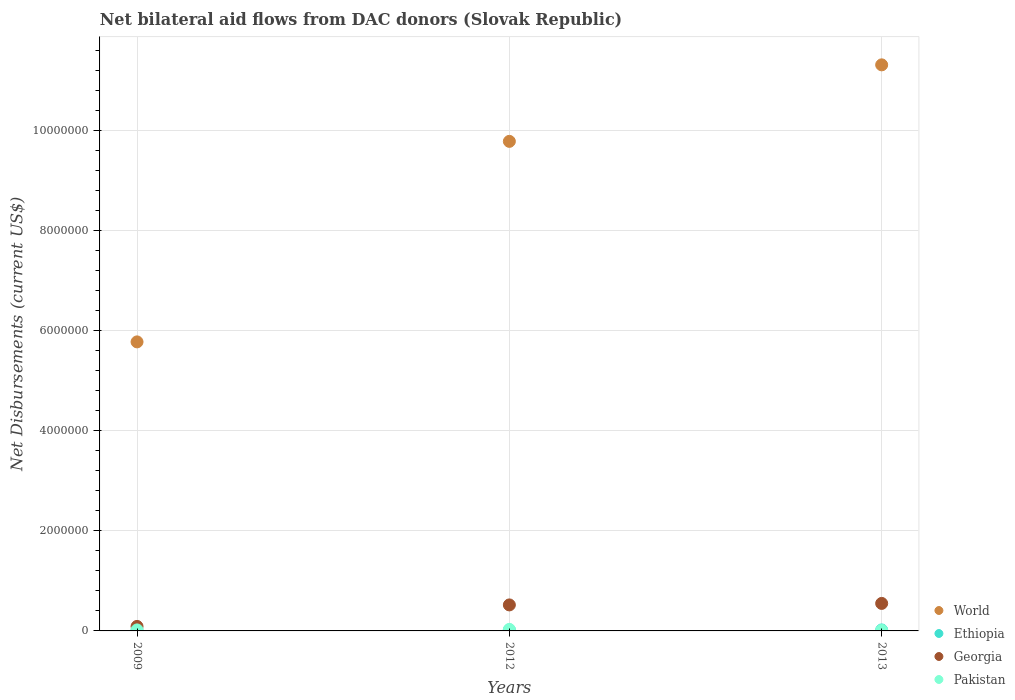Is the number of dotlines equal to the number of legend labels?
Your answer should be very brief. Yes. Across all years, what is the maximum net bilateral aid flows in Pakistan?
Your response must be concise. 3.00e+04. Across all years, what is the minimum net bilateral aid flows in World?
Your answer should be very brief. 5.78e+06. What is the total net bilateral aid flows in Pakistan in the graph?
Make the answer very short. 6.00e+04. What is the difference between the net bilateral aid flows in Georgia in 2013 and the net bilateral aid flows in Pakistan in 2012?
Your answer should be very brief. 5.20e+05. In the year 2009, what is the difference between the net bilateral aid flows in Pakistan and net bilateral aid flows in World?
Make the answer very short. -5.76e+06. What is the difference between the highest and the lowest net bilateral aid flows in Ethiopia?
Make the answer very short. 10000. Is the sum of the net bilateral aid flows in Ethiopia in 2012 and 2013 greater than the maximum net bilateral aid flows in World across all years?
Provide a succinct answer. No. Is it the case that in every year, the sum of the net bilateral aid flows in Pakistan and net bilateral aid flows in Georgia  is greater than the sum of net bilateral aid flows in Ethiopia and net bilateral aid flows in World?
Offer a very short reply. No. Does the net bilateral aid flows in Georgia monotonically increase over the years?
Keep it short and to the point. Yes. Is the net bilateral aid flows in World strictly greater than the net bilateral aid flows in Pakistan over the years?
Ensure brevity in your answer.  Yes. Are the values on the major ticks of Y-axis written in scientific E-notation?
Provide a succinct answer. No. Does the graph contain any zero values?
Offer a terse response. No. Does the graph contain grids?
Offer a terse response. Yes. How many legend labels are there?
Your answer should be very brief. 4. What is the title of the graph?
Your answer should be very brief. Net bilateral aid flows from DAC donors (Slovak Republic). Does "Latin America(developing only)" appear as one of the legend labels in the graph?
Provide a short and direct response. No. What is the label or title of the Y-axis?
Your response must be concise. Net Disbursements (current US$). What is the Net Disbursements (current US$) in World in 2009?
Give a very brief answer. 5.78e+06. What is the Net Disbursements (current US$) of Ethiopia in 2009?
Offer a very short reply. 10000. What is the Net Disbursements (current US$) in World in 2012?
Offer a very short reply. 9.79e+06. What is the Net Disbursements (current US$) of Ethiopia in 2012?
Your response must be concise. 2.00e+04. What is the Net Disbursements (current US$) in Georgia in 2012?
Provide a succinct answer. 5.20e+05. What is the Net Disbursements (current US$) in World in 2013?
Offer a very short reply. 1.13e+07. What is the Net Disbursements (current US$) of Ethiopia in 2013?
Your answer should be very brief. 2.00e+04. What is the Net Disbursements (current US$) in Georgia in 2013?
Your answer should be compact. 5.50e+05. Across all years, what is the maximum Net Disbursements (current US$) in World?
Give a very brief answer. 1.13e+07. Across all years, what is the maximum Net Disbursements (current US$) of Ethiopia?
Offer a terse response. 2.00e+04. Across all years, what is the minimum Net Disbursements (current US$) in World?
Provide a succinct answer. 5.78e+06. Across all years, what is the minimum Net Disbursements (current US$) in Ethiopia?
Your answer should be compact. 10000. Across all years, what is the minimum Net Disbursements (current US$) of Pakistan?
Provide a succinct answer. 10000. What is the total Net Disbursements (current US$) in World in the graph?
Offer a terse response. 2.69e+07. What is the total Net Disbursements (current US$) in Georgia in the graph?
Offer a terse response. 1.16e+06. What is the total Net Disbursements (current US$) of Pakistan in the graph?
Ensure brevity in your answer.  6.00e+04. What is the difference between the Net Disbursements (current US$) of World in 2009 and that in 2012?
Your answer should be very brief. -4.01e+06. What is the difference between the Net Disbursements (current US$) in Ethiopia in 2009 and that in 2012?
Your response must be concise. -10000. What is the difference between the Net Disbursements (current US$) in Georgia in 2009 and that in 2012?
Offer a terse response. -4.30e+05. What is the difference between the Net Disbursements (current US$) in Pakistan in 2009 and that in 2012?
Ensure brevity in your answer.  -10000. What is the difference between the Net Disbursements (current US$) of World in 2009 and that in 2013?
Your answer should be compact. -5.54e+06. What is the difference between the Net Disbursements (current US$) of Georgia in 2009 and that in 2013?
Your answer should be very brief. -4.60e+05. What is the difference between the Net Disbursements (current US$) in World in 2012 and that in 2013?
Your response must be concise. -1.53e+06. What is the difference between the Net Disbursements (current US$) in Ethiopia in 2012 and that in 2013?
Provide a short and direct response. 0. What is the difference between the Net Disbursements (current US$) of Pakistan in 2012 and that in 2013?
Make the answer very short. 2.00e+04. What is the difference between the Net Disbursements (current US$) in World in 2009 and the Net Disbursements (current US$) in Ethiopia in 2012?
Your response must be concise. 5.76e+06. What is the difference between the Net Disbursements (current US$) in World in 2009 and the Net Disbursements (current US$) in Georgia in 2012?
Your answer should be very brief. 5.26e+06. What is the difference between the Net Disbursements (current US$) in World in 2009 and the Net Disbursements (current US$) in Pakistan in 2012?
Make the answer very short. 5.75e+06. What is the difference between the Net Disbursements (current US$) in Ethiopia in 2009 and the Net Disbursements (current US$) in Georgia in 2012?
Your response must be concise. -5.10e+05. What is the difference between the Net Disbursements (current US$) of Ethiopia in 2009 and the Net Disbursements (current US$) of Pakistan in 2012?
Give a very brief answer. -2.00e+04. What is the difference between the Net Disbursements (current US$) in World in 2009 and the Net Disbursements (current US$) in Ethiopia in 2013?
Make the answer very short. 5.76e+06. What is the difference between the Net Disbursements (current US$) in World in 2009 and the Net Disbursements (current US$) in Georgia in 2013?
Keep it short and to the point. 5.23e+06. What is the difference between the Net Disbursements (current US$) of World in 2009 and the Net Disbursements (current US$) of Pakistan in 2013?
Your answer should be very brief. 5.77e+06. What is the difference between the Net Disbursements (current US$) of Ethiopia in 2009 and the Net Disbursements (current US$) of Georgia in 2013?
Provide a short and direct response. -5.40e+05. What is the difference between the Net Disbursements (current US$) in Georgia in 2009 and the Net Disbursements (current US$) in Pakistan in 2013?
Offer a very short reply. 8.00e+04. What is the difference between the Net Disbursements (current US$) in World in 2012 and the Net Disbursements (current US$) in Ethiopia in 2013?
Make the answer very short. 9.77e+06. What is the difference between the Net Disbursements (current US$) in World in 2012 and the Net Disbursements (current US$) in Georgia in 2013?
Your response must be concise. 9.24e+06. What is the difference between the Net Disbursements (current US$) of World in 2012 and the Net Disbursements (current US$) of Pakistan in 2013?
Your answer should be compact. 9.78e+06. What is the difference between the Net Disbursements (current US$) of Ethiopia in 2012 and the Net Disbursements (current US$) of Georgia in 2013?
Ensure brevity in your answer.  -5.30e+05. What is the difference between the Net Disbursements (current US$) in Ethiopia in 2012 and the Net Disbursements (current US$) in Pakistan in 2013?
Provide a succinct answer. 10000. What is the difference between the Net Disbursements (current US$) of Georgia in 2012 and the Net Disbursements (current US$) of Pakistan in 2013?
Keep it short and to the point. 5.10e+05. What is the average Net Disbursements (current US$) of World per year?
Make the answer very short. 8.96e+06. What is the average Net Disbursements (current US$) in Ethiopia per year?
Ensure brevity in your answer.  1.67e+04. What is the average Net Disbursements (current US$) of Georgia per year?
Keep it short and to the point. 3.87e+05. What is the average Net Disbursements (current US$) in Pakistan per year?
Provide a short and direct response. 2.00e+04. In the year 2009, what is the difference between the Net Disbursements (current US$) in World and Net Disbursements (current US$) in Ethiopia?
Offer a very short reply. 5.77e+06. In the year 2009, what is the difference between the Net Disbursements (current US$) of World and Net Disbursements (current US$) of Georgia?
Offer a very short reply. 5.69e+06. In the year 2009, what is the difference between the Net Disbursements (current US$) in World and Net Disbursements (current US$) in Pakistan?
Make the answer very short. 5.76e+06. In the year 2009, what is the difference between the Net Disbursements (current US$) in Ethiopia and Net Disbursements (current US$) in Georgia?
Keep it short and to the point. -8.00e+04. In the year 2009, what is the difference between the Net Disbursements (current US$) of Georgia and Net Disbursements (current US$) of Pakistan?
Offer a very short reply. 7.00e+04. In the year 2012, what is the difference between the Net Disbursements (current US$) in World and Net Disbursements (current US$) in Ethiopia?
Provide a short and direct response. 9.77e+06. In the year 2012, what is the difference between the Net Disbursements (current US$) in World and Net Disbursements (current US$) in Georgia?
Offer a very short reply. 9.27e+06. In the year 2012, what is the difference between the Net Disbursements (current US$) in World and Net Disbursements (current US$) in Pakistan?
Offer a very short reply. 9.76e+06. In the year 2012, what is the difference between the Net Disbursements (current US$) of Ethiopia and Net Disbursements (current US$) of Georgia?
Your response must be concise. -5.00e+05. In the year 2012, what is the difference between the Net Disbursements (current US$) of Georgia and Net Disbursements (current US$) of Pakistan?
Offer a terse response. 4.90e+05. In the year 2013, what is the difference between the Net Disbursements (current US$) in World and Net Disbursements (current US$) in Ethiopia?
Provide a succinct answer. 1.13e+07. In the year 2013, what is the difference between the Net Disbursements (current US$) in World and Net Disbursements (current US$) in Georgia?
Ensure brevity in your answer.  1.08e+07. In the year 2013, what is the difference between the Net Disbursements (current US$) in World and Net Disbursements (current US$) in Pakistan?
Ensure brevity in your answer.  1.13e+07. In the year 2013, what is the difference between the Net Disbursements (current US$) of Ethiopia and Net Disbursements (current US$) of Georgia?
Your answer should be very brief. -5.30e+05. In the year 2013, what is the difference between the Net Disbursements (current US$) in Ethiopia and Net Disbursements (current US$) in Pakistan?
Give a very brief answer. 10000. In the year 2013, what is the difference between the Net Disbursements (current US$) of Georgia and Net Disbursements (current US$) of Pakistan?
Offer a terse response. 5.40e+05. What is the ratio of the Net Disbursements (current US$) of World in 2009 to that in 2012?
Provide a succinct answer. 0.59. What is the ratio of the Net Disbursements (current US$) of Ethiopia in 2009 to that in 2012?
Your answer should be compact. 0.5. What is the ratio of the Net Disbursements (current US$) of Georgia in 2009 to that in 2012?
Keep it short and to the point. 0.17. What is the ratio of the Net Disbursements (current US$) of Pakistan in 2009 to that in 2012?
Give a very brief answer. 0.67. What is the ratio of the Net Disbursements (current US$) in World in 2009 to that in 2013?
Give a very brief answer. 0.51. What is the ratio of the Net Disbursements (current US$) in Ethiopia in 2009 to that in 2013?
Give a very brief answer. 0.5. What is the ratio of the Net Disbursements (current US$) in Georgia in 2009 to that in 2013?
Offer a terse response. 0.16. What is the ratio of the Net Disbursements (current US$) in Pakistan in 2009 to that in 2013?
Keep it short and to the point. 2. What is the ratio of the Net Disbursements (current US$) in World in 2012 to that in 2013?
Make the answer very short. 0.86. What is the ratio of the Net Disbursements (current US$) in Ethiopia in 2012 to that in 2013?
Keep it short and to the point. 1. What is the ratio of the Net Disbursements (current US$) of Georgia in 2012 to that in 2013?
Provide a short and direct response. 0.95. What is the ratio of the Net Disbursements (current US$) in Pakistan in 2012 to that in 2013?
Your answer should be compact. 3. What is the difference between the highest and the second highest Net Disbursements (current US$) of World?
Give a very brief answer. 1.53e+06. What is the difference between the highest and the second highest Net Disbursements (current US$) of Ethiopia?
Provide a succinct answer. 0. What is the difference between the highest and the lowest Net Disbursements (current US$) in World?
Your answer should be compact. 5.54e+06. 